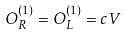Convert formula to latex. <formula><loc_0><loc_0><loc_500><loc_500>O _ { R } ^ { ( 1 ) } = O _ { L } ^ { ( 1 ) } = c V</formula> 